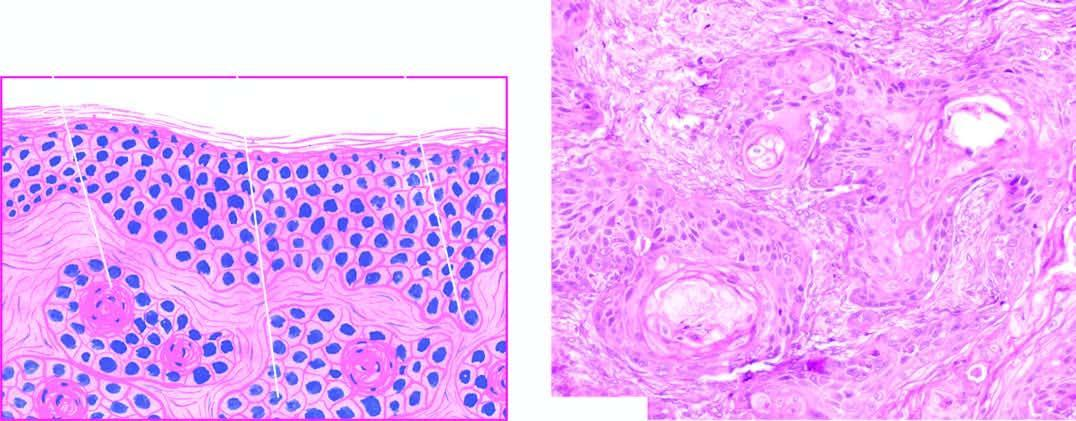s the dermis invaded by downward proliferating epidermal masses of cells which show atypical features?
Answer the question using a single word or phrase. Yes 